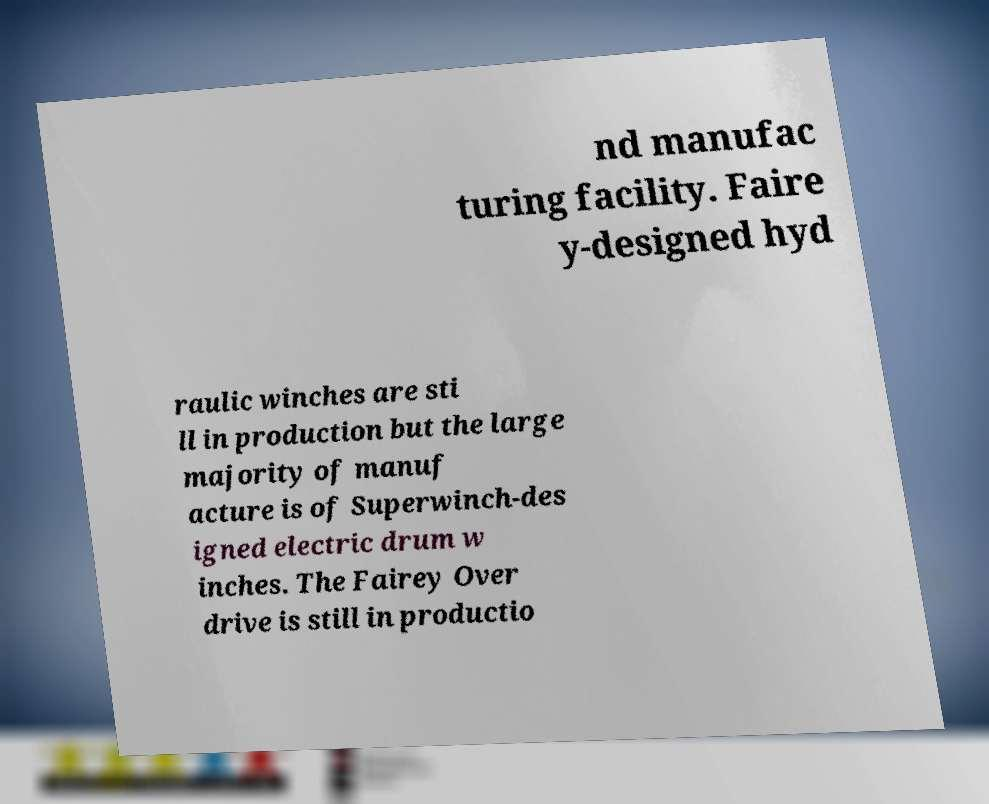Please read and relay the text visible in this image. What does it say? nd manufac turing facility. Faire y-designed hyd raulic winches are sti ll in production but the large majority of manuf acture is of Superwinch-des igned electric drum w inches. The Fairey Over drive is still in productio 